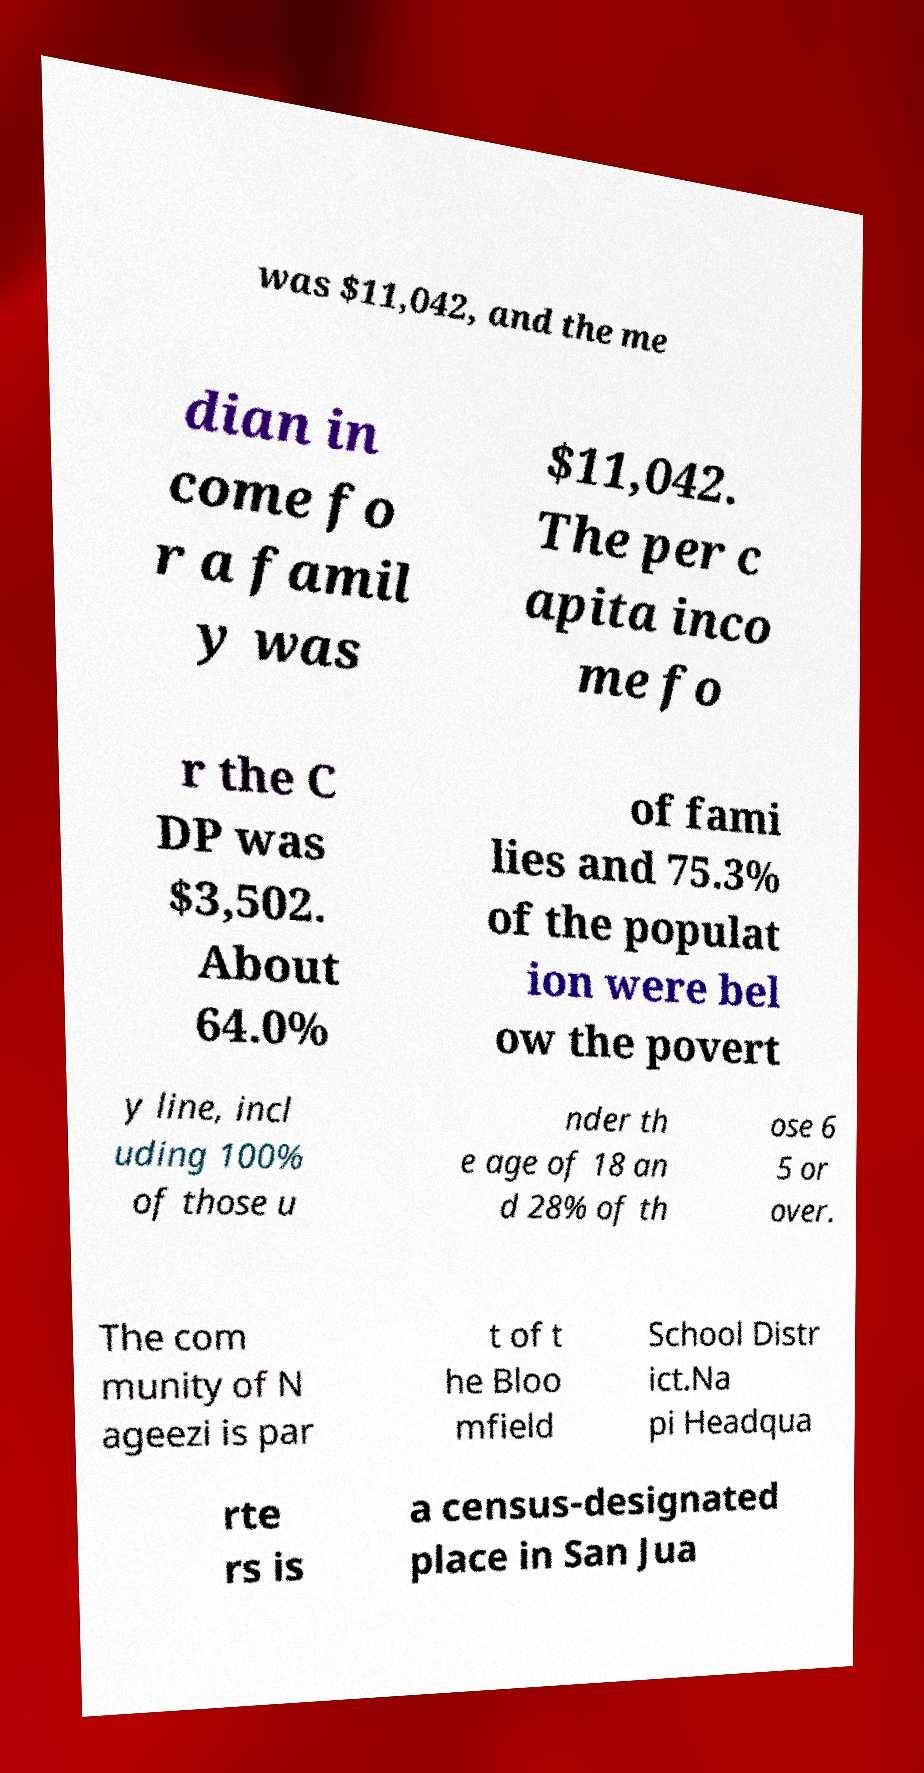There's text embedded in this image that I need extracted. Can you transcribe it verbatim? was $11,042, and the me dian in come fo r a famil y was $11,042. The per c apita inco me fo r the C DP was $3,502. About 64.0% of fami lies and 75.3% of the populat ion were bel ow the povert y line, incl uding 100% of those u nder th e age of 18 an d 28% of th ose 6 5 or over. The com munity of N ageezi is par t of t he Bloo mfield School Distr ict.Na pi Headqua rte rs is a census-designated place in San Jua 